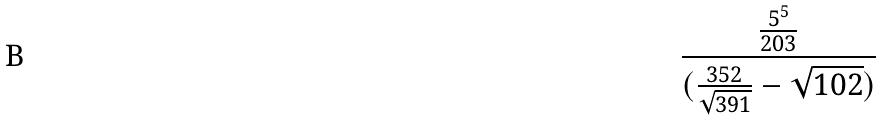Convert formula to latex. <formula><loc_0><loc_0><loc_500><loc_500>\frac { \frac { 5 ^ { 5 } } { 2 0 3 } } { ( \frac { 3 5 2 } { \sqrt { 3 9 1 } } - \sqrt { 1 0 2 } ) }</formula> 